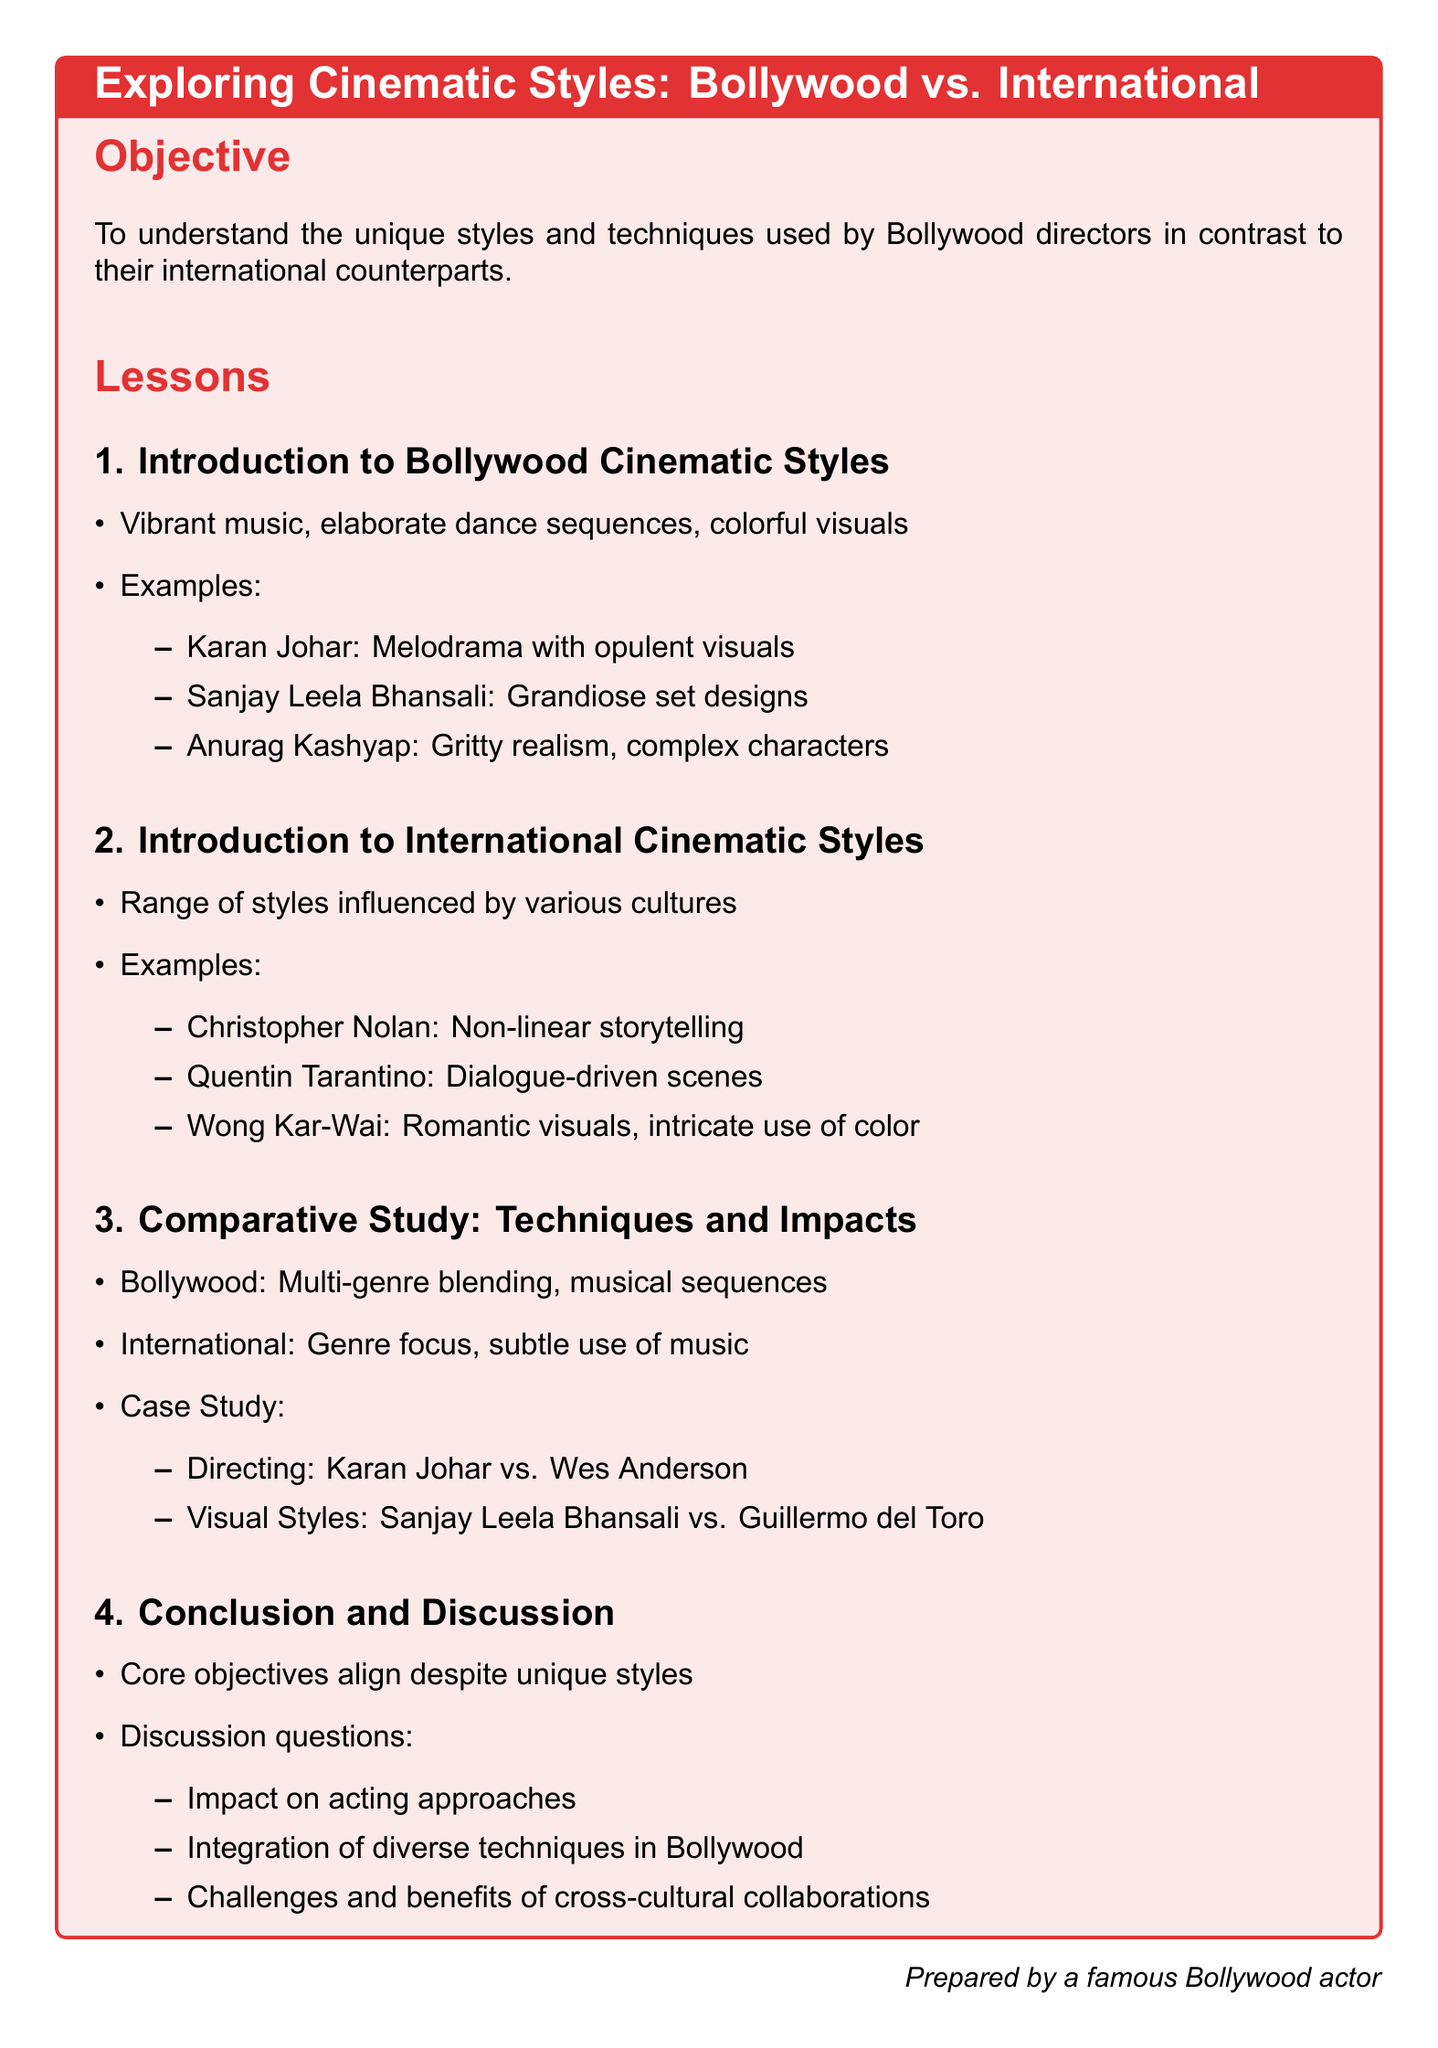What is the objective of the lesson plan? The objective is to understand the unique styles and techniques used by Bollywood directors in contrast to their international counterparts.
Answer: To understand unique styles Name one Bollywood director known for melodrama. Karan Johar is identified in the document for his melodrama and opulent visuals.
Answer: Karan Johar Which international director is known for non-linear storytelling? Christopher Nolan is specifically mentioned for his non-linear storytelling style in the document.
Answer: Christopher Nolan What type of approach does Sanjay Leela Bhansali use in his films? Sanjay Leela Bhansali is noted for grandiose set designs, which are part of his unique style.
Answer: Grandiose set designs What is a major technique used in Bollywood films as per the document? The document states that Bollywood films often blend multiple genres and include musical sequences.
Answer: Multi-genre blending Who is compared to Karan Johar in directing styles? Wes Anderson is the international director being compared to Karan Johar in the document.
Answer: Wes Anderson What is one discussion question included in the conclusion section? The document mentions several discussion questions including the impact on acting approaches.
Answer: Impact on acting approaches What color scheme is associated with the document's title box? The title box employs a color scheme reminiscent of Bollywood, specifically a shade referenced as Bollywood red.
Answer: Bollywood red 